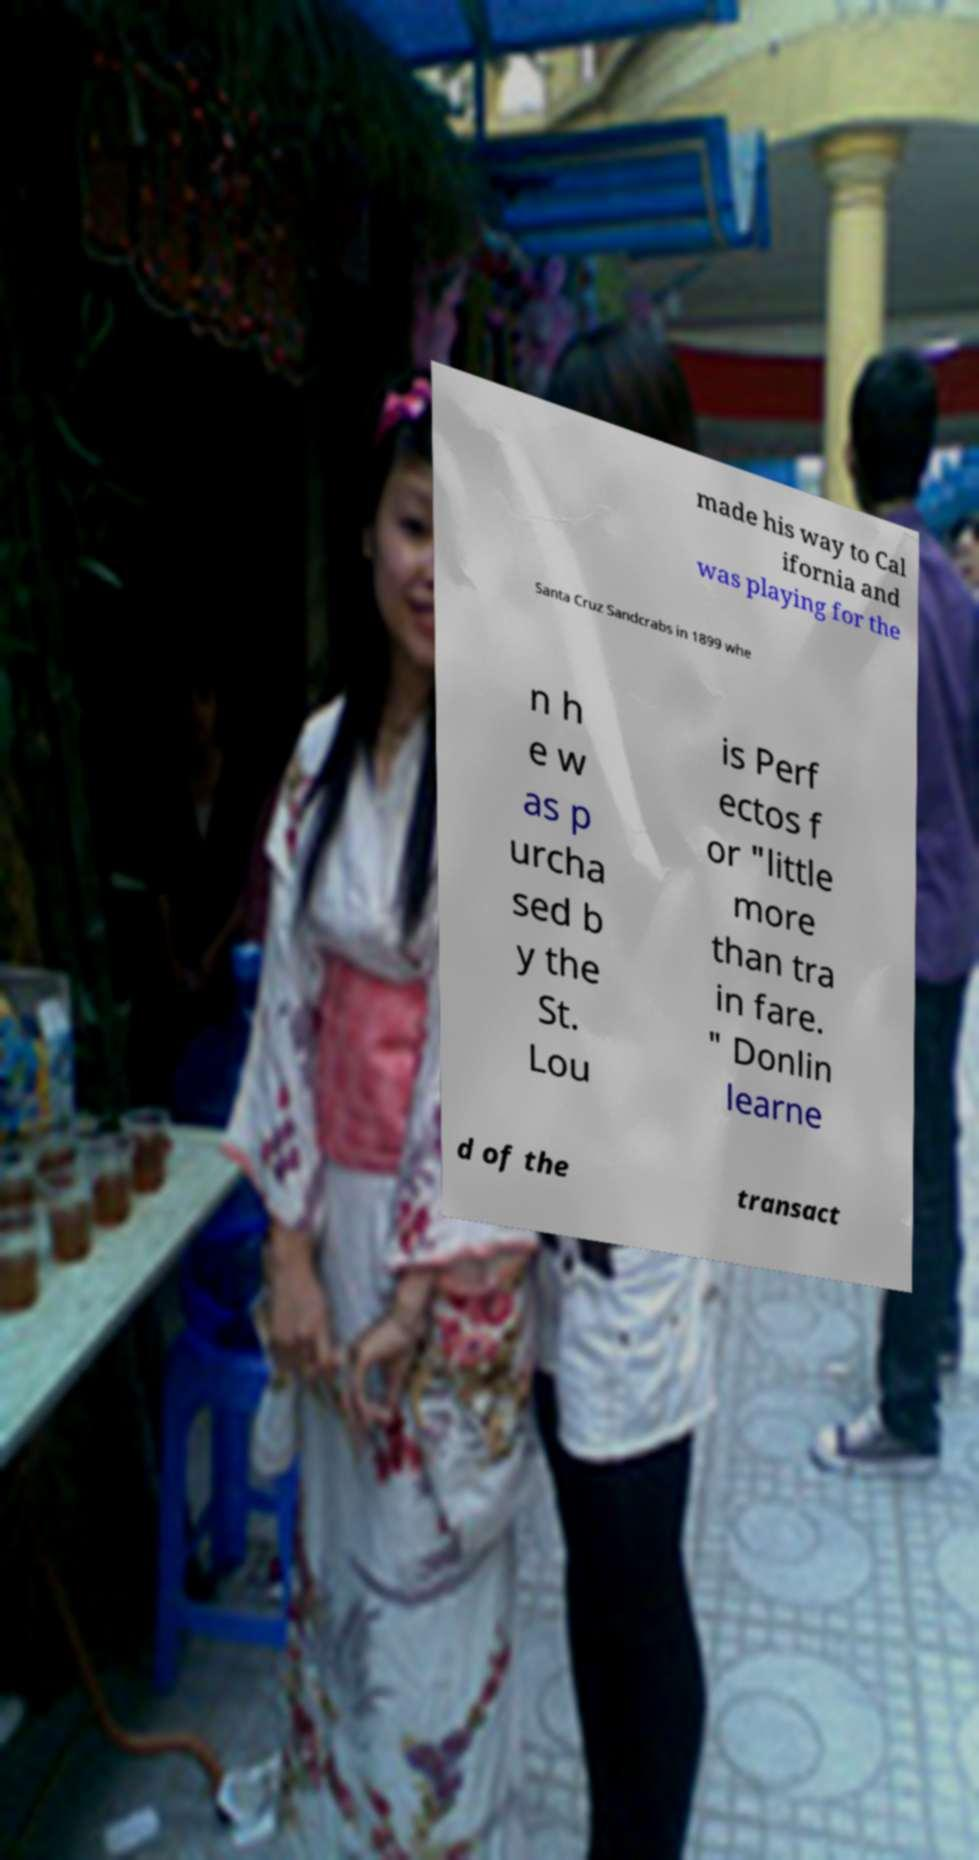There's text embedded in this image that I need extracted. Can you transcribe it verbatim? made his way to Cal ifornia and was playing for the Santa Cruz Sandcrabs in 1899 whe n h e w as p urcha sed b y the St. Lou is Perf ectos f or "little more than tra in fare. " Donlin learne d of the transact 